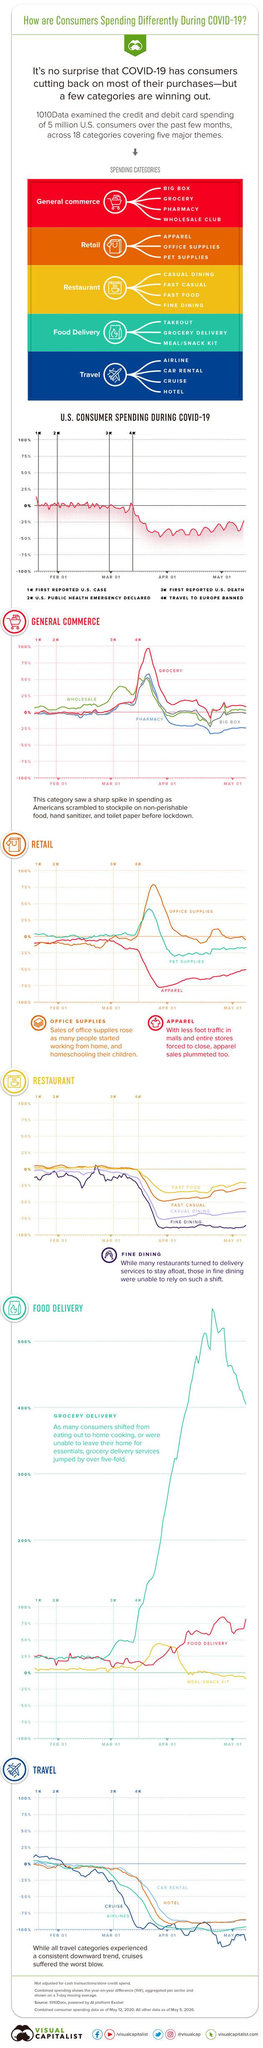Give some essential details in this illustration. A public health emergency was declared in the United States on January 31, February 1, March 1, and April 1. 